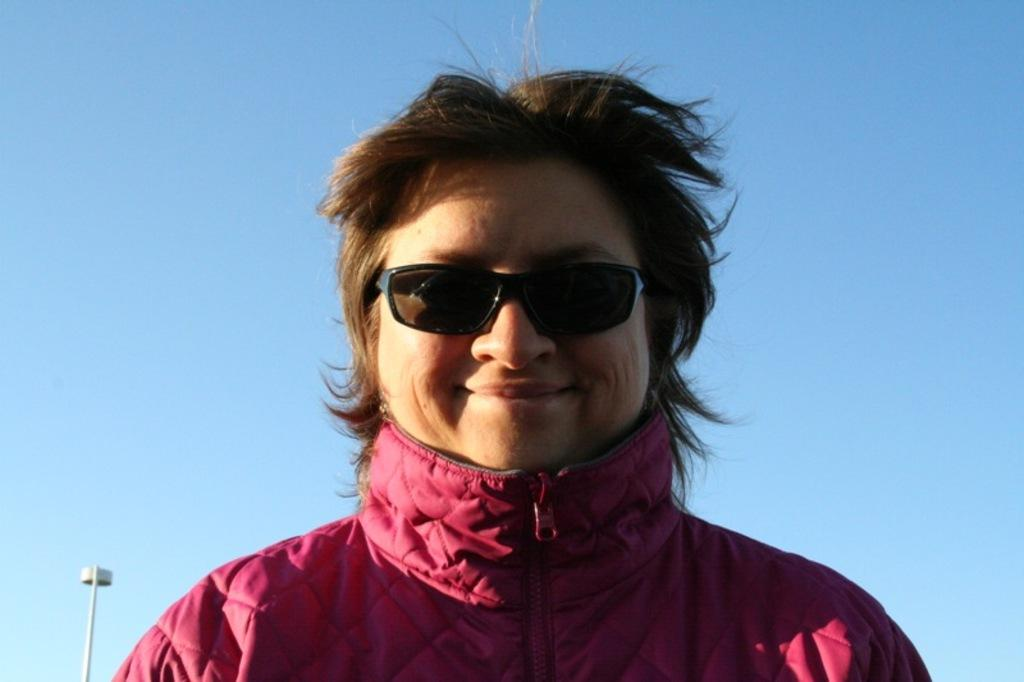Who is in the image? There is a person in the image. What is the person doing in the image? The person is smiling. What is the person wearing that is unique in the image? The person is wearing black color goggles. What can be seen in the background of the image? There is a pole in the background of the image. What is the color of the pole in the image? The pole is white in color. What advice does the person in the image give to their owner? There is no indication in the image that the person has an owner or is giving advice. 